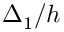<formula> <loc_0><loc_0><loc_500><loc_500>\Delta _ { 1 } / h</formula> 